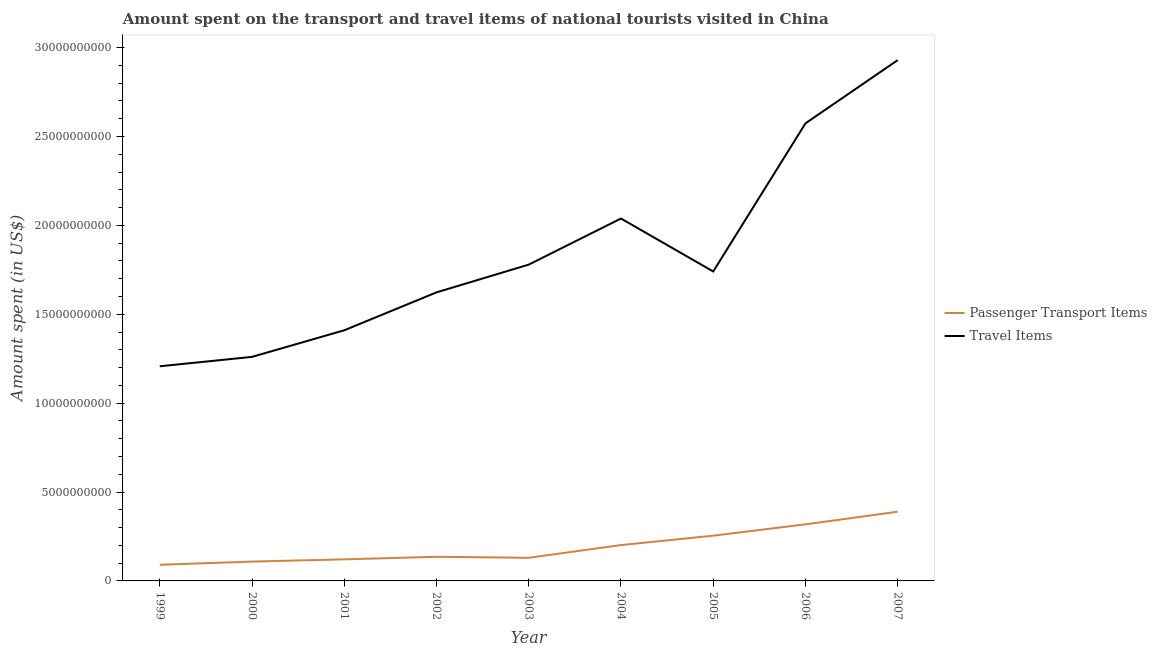Is the number of lines equal to the number of legend labels?
Your response must be concise. Yes. What is the amount spent in travel items in 2007?
Provide a succinct answer. 2.93e+1. Across all years, what is the maximum amount spent in travel items?
Offer a terse response. 2.93e+1. Across all years, what is the minimum amount spent on passenger transport items?
Your answer should be very brief. 9.08e+08. In which year was the amount spent on passenger transport items maximum?
Provide a succinct answer. 2007. What is the total amount spent in travel items in the graph?
Make the answer very short. 1.66e+11. What is the difference between the amount spent in travel items in 2003 and that in 2006?
Provide a succinct answer. -7.95e+09. What is the difference between the amount spent in travel items in 1999 and the amount spent on passenger transport items in 2004?
Your answer should be very brief. 1.01e+1. What is the average amount spent on passenger transport items per year?
Give a very brief answer. 1.94e+09. In the year 2003, what is the difference between the amount spent on passenger transport items and amount spent in travel items?
Provide a short and direct response. -1.65e+1. In how many years, is the amount spent on passenger transport items greater than 25000000000 US$?
Offer a very short reply. 0. What is the ratio of the amount spent on passenger transport items in 2001 to that in 2003?
Offer a terse response. 0.93. What is the difference between the highest and the second highest amount spent in travel items?
Provide a succinct answer. 3.56e+09. What is the difference between the highest and the lowest amount spent in travel items?
Offer a very short reply. 1.72e+1. Is the sum of the amount spent in travel items in 1999 and 2002 greater than the maximum amount spent on passenger transport items across all years?
Your response must be concise. Yes. Is the amount spent in travel items strictly less than the amount spent on passenger transport items over the years?
Offer a very short reply. No. What is the difference between two consecutive major ticks on the Y-axis?
Your answer should be compact. 5.00e+09. Does the graph contain grids?
Offer a terse response. No. How many legend labels are there?
Ensure brevity in your answer.  2. What is the title of the graph?
Keep it short and to the point. Amount spent on the transport and travel items of national tourists visited in China. What is the label or title of the Y-axis?
Offer a terse response. Amount spent (in US$). What is the Amount spent (in US$) in Passenger Transport Items in 1999?
Provide a succinct answer. 9.08e+08. What is the Amount spent (in US$) in Travel Items in 1999?
Provide a succinct answer. 1.21e+1. What is the Amount spent (in US$) of Passenger Transport Items in 2000?
Give a very brief answer. 1.09e+09. What is the Amount spent (in US$) of Travel Items in 2000?
Ensure brevity in your answer.  1.26e+1. What is the Amount spent (in US$) of Passenger Transport Items in 2001?
Ensure brevity in your answer.  1.21e+09. What is the Amount spent (in US$) in Travel Items in 2001?
Provide a short and direct response. 1.41e+1. What is the Amount spent (in US$) of Passenger Transport Items in 2002?
Give a very brief answer. 1.36e+09. What is the Amount spent (in US$) of Travel Items in 2002?
Provide a short and direct response. 1.62e+1. What is the Amount spent (in US$) in Passenger Transport Items in 2003?
Your answer should be very brief. 1.30e+09. What is the Amount spent (in US$) of Travel Items in 2003?
Make the answer very short. 1.78e+1. What is the Amount spent (in US$) of Passenger Transport Items in 2004?
Offer a terse response. 2.02e+09. What is the Amount spent (in US$) in Travel Items in 2004?
Your answer should be compact. 2.04e+1. What is the Amount spent (in US$) of Passenger Transport Items in 2005?
Ensure brevity in your answer.  2.55e+09. What is the Amount spent (in US$) in Travel Items in 2005?
Offer a terse response. 1.74e+1. What is the Amount spent (in US$) in Passenger Transport Items in 2006?
Your answer should be compact. 3.18e+09. What is the Amount spent (in US$) in Travel Items in 2006?
Make the answer very short. 2.57e+1. What is the Amount spent (in US$) in Passenger Transport Items in 2007?
Your answer should be very brief. 3.89e+09. What is the Amount spent (in US$) in Travel Items in 2007?
Keep it short and to the point. 2.93e+1. Across all years, what is the maximum Amount spent (in US$) in Passenger Transport Items?
Ensure brevity in your answer.  3.89e+09. Across all years, what is the maximum Amount spent (in US$) of Travel Items?
Make the answer very short. 2.93e+1. Across all years, what is the minimum Amount spent (in US$) in Passenger Transport Items?
Make the answer very short. 9.08e+08. Across all years, what is the minimum Amount spent (in US$) in Travel Items?
Offer a very short reply. 1.21e+1. What is the total Amount spent (in US$) of Passenger Transport Items in the graph?
Give a very brief answer. 1.75e+1. What is the total Amount spent (in US$) in Travel Items in the graph?
Keep it short and to the point. 1.66e+11. What is the difference between the Amount spent (in US$) of Passenger Transport Items in 1999 and that in 2000?
Offer a terse response. -1.79e+08. What is the difference between the Amount spent (in US$) in Travel Items in 1999 and that in 2000?
Provide a short and direct response. -5.28e+08. What is the difference between the Amount spent (in US$) in Passenger Transport Items in 1999 and that in 2001?
Offer a very short reply. -3.06e+08. What is the difference between the Amount spent (in US$) of Travel Items in 1999 and that in 2001?
Keep it short and to the point. -2.02e+09. What is the difference between the Amount spent (in US$) in Passenger Transport Items in 1999 and that in 2002?
Keep it short and to the point. -4.49e+08. What is the difference between the Amount spent (in US$) in Travel Items in 1999 and that in 2002?
Make the answer very short. -4.16e+09. What is the difference between the Amount spent (in US$) of Passenger Transport Items in 1999 and that in 2003?
Make the answer very short. -3.93e+08. What is the difference between the Amount spent (in US$) in Travel Items in 1999 and that in 2003?
Give a very brief answer. -5.72e+09. What is the difference between the Amount spent (in US$) in Passenger Transport Items in 1999 and that in 2004?
Offer a very short reply. -1.11e+09. What is the difference between the Amount spent (in US$) of Travel Items in 1999 and that in 2004?
Offer a very short reply. -8.31e+09. What is the difference between the Amount spent (in US$) of Passenger Transport Items in 1999 and that in 2005?
Provide a succinct answer. -1.64e+09. What is the difference between the Amount spent (in US$) of Travel Items in 1999 and that in 2005?
Your answer should be very brief. -5.33e+09. What is the difference between the Amount spent (in US$) in Passenger Transport Items in 1999 and that in 2006?
Provide a short and direct response. -2.28e+09. What is the difference between the Amount spent (in US$) in Travel Items in 1999 and that in 2006?
Your answer should be compact. -1.37e+1. What is the difference between the Amount spent (in US$) of Passenger Transport Items in 1999 and that in 2007?
Ensure brevity in your answer.  -2.98e+09. What is the difference between the Amount spent (in US$) in Travel Items in 1999 and that in 2007?
Your answer should be compact. -1.72e+1. What is the difference between the Amount spent (in US$) in Passenger Transport Items in 2000 and that in 2001?
Offer a terse response. -1.27e+08. What is the difference between the Amount spent (in US$) of Travel Items in 2000 and that in 2001?
Keep it short and to the point. -1.50e+09. What is the difference between the Amount spent (in US$) in Passenger Transport Items in 2000 and that in 2002?
Offer a very short reply. -2.70e+08. What is the difference between the Amount spent (in US$) of Travel Items in 2000 and that in 2002?
Provide a short and direct response. -3.63e+09. What is the difference between the Amount spent (in US$) in Passenger Transport Items in 2000 and that in 2003?
Your answer should be very brief. -2.14e+08. What is the difference between the Amount spent (in US$) of Travel Items in 2000 and that in 2003?
Make the answer very short. -5.19e+09. What is the difference between the Amount spent (in US$) in Passenger Transport Items in 2000 and that in 2004?
Provide a short and direct response. -9.29e+08. What is the difference between the Amount spent (in US$) of Travel Items in 2000 and that in 2004?
Your answer should be very brief. -7.78e+09. What is the difference between the Amount spent (in US$) of Passenger Transport Items in 2000 and that in 2005?
Offer a very short reply. -1.46e+09. What is the difference between the Amount spent (in US$) of Travel Items in 2000 and that in 2005?
Offer a very short reply. -4.80e+09. What is the difference between the Amount spent (in US$) in Passenger Transport Items in 2000 and that in 2006?
Give a very brief answer. -2.10e+09. What is the difference between the Amount spent (in US$) in Travel Items in 2000 and that in 2006?
Ensure brevity in your answer.  -1.31e+1. What is the difference between the Amount spent (in US$) of Passenger Transport Items in 2000 and that in 2007?
Your response must be concise. -2.81e+09. What is the difference between the Amount spent (in US$) of Travel Items in 2000 and that in 2007?
Your answer should be very brief. -1.67e+1. What is the difference between the Amount spent (in US$) in Passenger Transport Items in 2001 and that in 2002?
Make the answer very short. -1.43e+08. What is the difference between the Amount spent (in US$) in Travel Items in 2001 and that in 2002?
Offer a terse response. -2.13e+09. What is the difference between the Amount spent (in US$) in Passenger Transport Items in 2001 and that in 2003?
Your answer should be very brief. -8.70e+07. What is the difference between the Amount spent (in US$) of Travel Items in 2001 and that in 2003?
Make the answer very short. -3.69e+09. What is the difference between the Amount spent (in US$) of Passenger Transport Items in 2001 and that in 2004?
Provide a short and direct response. -8.02e+08. What is the difference between the Amount spent (in US$) in Travel Items in 2001 and that in 2004?
Offer a very short reply. -6.29e+09. What is the difference between the Amount spent (in US$) in Passenger Transport Items in 2001 and that in 2005?
Your answer should be very brief. -1.33e+09. What is the difference between the Amount spent (in US$) of Travel Items in 2001 and that in 2005?
Your answer should be compact. -3.31e+09. What is the difference between the Amount spent (in US$) in Passenger Transport Items in 2001 and that in 2006?
Provide a short and direct response. -1.97e+09. What is the difference between the Amount spent (in US$) in Travel Items in 2001 and that in 2006?
Provide a short and direct response. -1.16e+1. What is the difference between the Amount spent (in US$) in Passenger Transport Items in 2001 and that in 2007?
Your response must be concise. -2.68e+09. What is the difference between the Amount spent (in US$) in Travel Items in 2001 and that in 2007?
Your answer should be compact. -1.52e+1. What is the difference between the Amount spent (in US$) in Passenger Transport Items in 2002 and that in 2003?
Your answer should be compact. 5.60e+07. What is the difference between the Amount spent (in US$) of Travel Items in 2002 and that in 2003?
Ensure brevity in your answer.  -1.56e+09. What is the difference between the Amount spent (in US$) in Passenger Transport Items in 2002 and that in 2004?
Offer a terse response. -6.59e+08. What is the difference between the Amount spent (in US$) in Travel Items in 2002 and that in 2004?
Provide a short and direct response. -4.15e+09. What is the difference between the Amount spent (in US$) in Passenger Transport Items in 2002 and that in 2005?
Provide a succinct answer. -1.19e+09. What is the difference between the Amount spent (in US$) in Travel Items in 2002 and that in 2005?
Provide a succinct answer. -1.18e+09. What is the difference between the Amount spent (in US$) of Passenger Transport Items in 2002 and that in 2006?
Offer a very short reply. -1.83e+09. What is the difference between the Amount spent (in US$) in Travel Items in 2002 and that in 2006?
Ensure brevity in your answer.  -9.51e+09. What is the difference between the Amount spent (in US$) of Passenger Transport Items in 2002 and that in 2007?
Your response must be concise. -2.54e+09. What is the difference between the Amount spent (in US$) of Travel Items in 2002 and that in 2007?
Your answer should be compact. -1.31e+1. What is the difference between the Amount spent (in US$) of Passenger Transport Items in 2003 and that in 2004?
Provide a short and direct response. -7.15e+08. What is the difference between the Amount spent (in US$) in Travel Items in 2003 and that in 2004?
Keep it short and to the point. -2.59e+09. What is the difference between the Amount spent (in US$) of Passenger Transport Items in 2003 and that in 2005?
Provide a short and direct response. -1.24e+09. What is the difference between the Amount spent (in US$) in Travel Items in 2003 and that in 2005?
Your answer should be very brief. 3.86e+08. What is the difference between the Amount spent (in US$) in Passenger Transport Items in 2003 and that in 2006?
Your answer should be very brief. -1.88e+09. What is the difference between the Amount spent (in US$) in Travel Items in 2003 and that in 2006?
Offer a terse response. -7.95e+09. What is the difference between the Amount spent (in US$) of Passenger Transport Items in 2003 and that in 2007?
Your answer should be compact. -2.59e+09. What is the difference between the Amount spent (in US$) of Travel Items in 2003 and that in 2007?
Your answer should be compact. -1.15e+1. What is the difference between the Amount spent (in US$) in Passenger Transport Items in 2004 and that in 2005?
Your answer should be very brief. -5.30e+08. What is the difference between the Amount spent (in US$) of Travel Items in 2004 and that in 2005?
Provide a succinct answer. 2.98e+09. What is the difference between the Amount spent (in US$) of Passenger Transport Items in 2004 and that in 2006?
Make the answer very short. -1.17e+09. What is the difference between the Amount spent (in US$) of Travel Items in 2004 and that in 2006?
Your answer should be very brief. -5.35e+09. What is the difference between the Amount spent (in US$) of Passenger Transport Items in 2004 and that in 2007?
Your answer should be compact. -1.88e+09. What is the difference between the Amount spent (in US$) of Travel Items in 2004 and that in 2007?
Your answer should be compact. -8.91e+09. What is the difference between the Amount spent (in US$) in Passenger Transport Items in 2005 and that in 2006?
Make the answer very short. -6.37e+08. What is the difference between the Amount spent (in US$) in Travel Items in 2005 and that in 2006?
Your answer should be very brief. -8.33e+09. What is the difference between the Amount spent (in US$) in Passenger Transport Items in 2005 and that in 2007?
Offer a very short reply. -1.35e+09. What is the difference between the Amount spent (in US$) in Travel Items in 2005 and that in 2007?
Your response must be concise. -1.19e+1. What is the difference between the Amount spent (in US$) in Passenger Transport Items in 2006 and that in 2007?
Ensure brevity in your answer.  -7.10e+08. What is the difference between the Amount spent (in US$) in Travel Items in 2006 and that in 2007?
Provide a succinct answer. -3.56e+09. What is the difference between the Amount spent (in US$) in Passenger Transport Items in 1999 and the Amount spent (in US$) in Travel Items in 2000?
Provide a succinct answer. -1.17e+1. What is the difference between the Amount spent (in US$) of Passenger Transport Items in 1999 and the Amount spent (in US$) of Travel Items in 2001?
Your answer should be very brief. -1.32e+1. What is the difference between the Amount spent (in US$) of Passenger Transport Items in 1999 and the Amount spent (in US$) of Travel Items in 2002?
Your response must be concise. -1.53e+1. What is the difference between the Amount spent (in US$) in Passenger Transport Items in 1999 and the Amount spent (in US$) in Travel Items in 2003?
Ensure brevity in your answer.  -1.69e+1. What is the difference between the Amount spent (in US$) in Passenger Transport Items in 1999 and the Amount spent (in US$) in Travel Items in 2004?
Offer a terse response. -1.95e+1. What is the difference between the Amount spent (in US$) of Passenger Transport Items in 1999 and the Amount spent (in US$) of Travel Items in 2005?
Your response must be concise. -1.65e+1. What is the difference between the Amount spent (in US$) of Passenger Transport Items in 1999 and the Amount spent (in US$) of Travel Items in 2006?
Keep it short and to the point. -2.48e+1. What is the difference between the Amount spent (in US$) of Passenger Transport Items in 1999 and the Amount spent (in US$) of Travel Items in 2007?
Your answer should be very brief. -2.84e+1. What is the difference between the Amount spent (in US$) in Passenger Transport Items in 2000 and the Amount spent (in US$) in Travel Items in 2001?
Provide a short and direct response. -1.30e+1. What is the difference between the Amount spent (in US$) in Passenger Transport Items in 2000 and the Amount spent (in US$) in Travel Items in 2002?
Provide a short and direct response. -1.51e+1. What is the difference between the Amount spent (in US$) in Passenger Transport Items in 2000 and the Amount spent (in US$) in Travel Items in 2003?
Your answer should be compact. -1.67e+1. What is the difference between the Amount spent (in US$) of Passenger Transport Items in 2000 and the Amount spent (in US$) of Travel Items in 2004?
Provide a short and direct response. -1.93e+1. What is the difference between the Amount spent (in US$) of Passenger Transport Items in 2000 and the Amount spent (in US$) of Travel Items in 2005?
Ensure brevity in your answer.  -1.63e+1. What is the difference between the Amount spent (in US$) of Passenger Transport Items in 2000 and the Amount spent (in US$) of Travel Items in 2006?
Make the answer very short. -2.47e+1. What is the difference between the Amount spent (in US$) in Passenger Transport Items in 2000 and the Amount spent (in US$) in Travel Items in 2007?
Offer a very short reply. -2.82e+1. What is the difference between the Amount spent (in US$) of Passenger Transport Items in 2001 and the Amount spent (in US$) of Travel Items in 2002?
Provide a short and direct response. -1.50e+1. What is the difference between the Amount spent (in US$) in Passenger Transport Items in 2001 and the Amount spent (in US$) in Travel Items in 2003?
Your answer should be compact. -1.66e+1. What is the difference between the Amount spent (in US$) in Passenger Transport Items in 2001 and the Amount spent (in US$) in Travel Items in 2004?
Give a very brief answer. -1.92e+1. What is the difference between the Amount spent (in US$) in Passenger Transport Items in 2001 and the Amount spent (in US$) in Travel Items in 2005?
Your response must be concise. -1.62e+1. What is the difference between the Amount spent (in US$) of Passenger Transport Items in 2001 and the Amount spent (in US$) of Travel Items in 2006?
Keep it short and to the point. -2.45e+1. What is the difference between the Amount spent (in US$) of Passenger Transport Items in 2001 and the Amount spent (in US$) of Travel Items in 2007?
Ensure brevity in your answer.  -2.81e+1. What is the difference between the Amount spent (in US$) of Passenger Transport Items in 2002 and the Amount spent (in US$) of Travel Items in 2003?
Ensure brevity in your answer.  -1.64e+1. What is the difference between the Amount spent (in US$) in Passenger Transport Items in 2002 and the Amount spent (in US$) in Travel Items in 2004?
Your answer should be very brief. -1.90e+1. What is the difference between the Amount spent (in US$) in Passenger Transport Items in 2002 and the Amount spent (in US$) in Travel Items in 2005?
Your response must be concise. -1.60e+1. What is the difference between the Amount spent (in US$) of Passenger Transport Items in 2002 and the Amount spent (in US$) of Travel Items in 2006?
Provide a succinct answer. -2.44e+1. What is the difference between the Amount spent (in US$) of Passenger Transport Items in 2002 and the Amount spent (in US$) of Travel Items in 2007?
Provide a short and direct response. -2.79e+1. What is the difference between the Amount spent (in US$) of Passenger Transport Items in 2003 and the Amount spent (in US$) of Travel Items in 2004?
Your response must be concise. -1.91e+1. What is the difference between the Amount spent (in US$) of Passenger Transport Items in 2003 and the Amount spent (in US$) of Travel Items in 2005?
Provide a short and direct response. -1.61e+1. What is the difference between the Amount spent (in US$) of Passenger Transport Items in 2003 and the Amount spent (in US$) of Travel Items in 2006?
Make the answer very short. -2.44e+1. What is the difference between the Amount spent (in US$) of Passenger Transport Items in 2003 and the Amount spent (in US$) of Travel Items in 2007?
Your answer should be compact. -2.80e+1. What is the difference between the Amount spent (in US$) in Passenger Transport Items in 2004 and the Amount spent (in US$) in Travel Items in 2005?
Your answer should be very brief. -1.54e+1. What is the difference between the Amount spent (in US$) in Passenger Transport Items in 2004 and the Amount spent (in US$) in Travel Items in 2006?
Ensure brevity in your answer.  -2.37e+1. What is the difference between the Amount spent (in US$) in Passenger Transport Items in 2004 and the Amount spent (in US$) in Travel Items in 2007?
Keep it short and to the point. -2.73e+1. What is the difference between the Amount spent (in US$) of Passenger Transport Items in 2005 and the Amount spent (in US$) of Travel Items in 2006?
Give a very brief answer. -2.32e+1. What is the difference between the Amount spent (in US$) of Passenger Transport Items in 2005 and the Amount spent (in US$) of Travel Items in 2007?
Provide a short and direct response. -2.68e+1. What is the difference between the Amount spent (in US$) of Passenger Transport Items in 2006 and the Amount spent (in US$) of Travel Items in 2007?
Keep it short and to the point. -2.61e+1. What is the average Amount spent (in US$) in Passenger Transport Items per year?
Your response must be concise. 1.94e+09. What is the average Amount spent (in US$) of Travel Items per year?
Offer a terse response. 1.84e+1. In the year 1999, what is the difference between the Amount spent (in US$) in Passenger Transport Items and Amount spent (in US$) in Travel Items?
Make the answer very short. -1.12e+1. In the year 2000, what is the difference between the Amount spent (in US$) of Passenger Transport Items and Amount spent (in US$) of Travel Items?
Your answer should be compact. -1.15e+1. In the year 2001, what is the difference between the Amount spent (in US$) in Passenger Transport Items and Amount spent (in US$) in Travel Items?
Your response must be concise. -1.29e+1. In the year 2002, what is the difference between the Amount spent (in US$) in Passenger Transport Items and Amount spent (in US$) in Travel Items?
Keep it short and to the point. -1.49e+1. In the year 2003, what is the difference between the Amount spent (in US$) of Passenger Transport Items and Amount spent (in US$) of Travel Items?
Give a very brief answer. -1.65e+1. In the year 2004, what is the difference between the Amount spent (in US$) of Passenger Transport Items and Amount spent (in US$) of Travel Items?
Provide a short and direct response. -1.84e+1. In the year 2005, what is the difference between the Amount spent (in US$) in Passenger Transport Items and Amount spent (in US$) in Travel Items?
Give a very brief answer. -1.49e+1. In the year 2006, what is the difference between the Amount spent (in US$) of Passenger Transport Items and Amount spent (in US$) of Travel Items?
Offer a terse response. -2.26e+1. In the year 2007, what is the difference between the Amount spent (in US$) in Passenger Transport Items and Amount spent (in US$) in Travel Items?
Your answer should be very brief. -2.54e+1. What is the ratio of the Amount spent (in US$) of Passenger Transport Items in 1999 to that in 2000?
Provide a short and direct response. 0.84. What is the ratio of the Amount spent (in US$) in Travel Items in 1999 to that in 2000?
Offer a very short reply. 0.96. What is the ratio of the Amount spent (in US$) in Passenger Transport Items in 1999 to that in 2001?
Ensure brevity in your answer.  0.75. What is the ratio of the Amount spent (in US$) of Travel Items in 1999 to that in 2001?
Ensure brevity in your answer.  0.86. What is the ratio of the Amount spent (in US$) of Passenger Transport Items in 1999 to that in 2002?
Your response must be concise. 0.67. What is the ratio of the Amount spent (in US$) of Travel Items in 1999 to that in 2002?
Ensure brevity in your answer.  0.74. What is the ratio of the Amount spent (in US$) of Passenger Transport Items in 1999 to that in 2003?
Make the answer very short. 0.7. What is the ratio of the Amount spent (in US$) in Travel Items in 1999 to that in 2003?
Keep it short and to the point. 0.68. What is the ratio of the Amount spent (in US$) of Passenger Transport Items in 1999 to that in 2004?
Your answer should be compact. 0.45. What is the ratio of the Amount spent (in US$) of Travel Items in 1999 to that in 2004?
Ensure brevity in your answer.  0.59. What is the ratio of the Amount spent (in US$) in Passenger Transport Items in 1999 to that in 2005?
Provide a succinct answer. 0.36. What is the ratio of the Amount spent (in US$) of Travel Items in 1999 to that in 2005?
Make the answer very short. 0.69. What is the ratio of the Amount spent (in US$) in Passenger Transport Items in 1999 to that in 2006?
Give a very brief answer. 0.29. What is the ratio of the Amount spent (in US$) of Travel Items in 1999 to that in 2006?
Ensure brevity in your answer.  0.47. What is the ratio of the Amount spent (in US$) of Passenger Transport Items in 1999 to that in 2007?
Provide a short and direct response. 0.23. What is the ratio of the Amount spent (in US$) in Travel Items in 1999 to that in 2007?
Your answer should be very brief. 0.41. What is the ratio of the Amount spent (in US$) in Passenger Transport Items in 2000 to that in 2001?
Provide a short and direct response. 0.9. What is the ratio of the Amount spent (in US$) in Travel Items in 2000 to that in 2001?
Provide a succinct answer. 0.89. What is the ratio of the Amount spent (in US$) in Passenger Transport Items in 2000 to that in 2002?
Make the answer very short. 0.8. What is the ratio of the Amount spent (in US$) of Travel Items in 2000 to that in 2002?
Provide a short and direct response. 0.78. What is the ratio of the Amount spent (in US$) in Passenger Transport Items in 2000 to that in 2003?
Your response must be concise. 0.84. What is the ratio of the Amount spent (in US$) in Travel Items in 2000 to that in 2003?
Keep it short and to the point. 0.71. What is the ratio of the Amount spent (in US$) in Passenger Transport Items in 2000 to that in 2004?
Provide a short and direct response. 0.54. What is the ratio of the Amount spent (in US$) of Travel Items in 2000 to that in 2004?
Provide a short and direct response. 0.62. What is the ratio of the Amount spent (in US$) of Passenger Transport Items in 2000 to that in 2005?
Provide a succinct answer. 0.43. What is the ratio of the Amount spent (in US$) in Travel Items in 2000 to that in 2005?
Give a very brief answer. 0.72. What is the ratio of the Amount spent (in US$) in Passenger Transport Items in 2000 to that in 2006?
Your answer should be very brief. 0.34. What is the ratio of the Amount spent (in US$) in Travel Items in 2000 to that in 2006?
Keep it short and to the point. 0.49. What is the ratio of the Amount spent (in US$) of Passenger Transport Items in 2000 to that in 2007?
Give a very brief answer. 0.28. What is the ratio of the Amount spent (in US$) of Travel Items in 2000 to that in 2007?
Keep it short and to the point. 0.43. What is the ratio of the Amount spent (in US$) in Passenger Transport Items in 2001 to that in 2002?
Your response must be concise. 0.89. What is the ratio of the Amount spent (in US$) in Travel Items in 2001 to that in 2002?
Provide a short and direct response. 0.87. What is the ratio of the Amount spent (in US$) of Passenger Transport Items in 2001 to that in 2003?
Offer a very short reply. 0.93. What is the ratio of the Amount spent (in US$) in Travel Items in 2001 to that in 2003?
Give a very brief answer. 0.79. What is the ratio of the Amount spent (in US$) of Passenger Transport Items in 2001 to that in 2004?
Your answer should be compact. 0.6. What is the ratio of the Amount spent (in US$) in Travel Items in 2001 to that in 2004?
Keep it short and to the point. 0.69. What is the ratio of the Amount spent (in US$) in Passenger Transport Items in 2001 to that in 2005?
Make the answer very short. 0.48. What is the ratio of the Amount spent (in US$) of Travel Items in 2001 to that in 2005?
Your answer should be very brief. 0.81. What is the ratio of the Amount spent (in US$) in Passenger Transport Items in 2001 to that in 2006?
Your response must be concise. 0.38. What is the ratio of the Amount spent (in US$) in Travel Items in 2001 to that in 2006?
Provide a succinct answer. 0.55. What is the ratio of the Amount spent (in US$) of Passenger Transport Items in 2001 to that in 2007?
Make the answer very short. 0.31. What is the ratio of the Amount spent (in US$) of Travel Items in 2001 to that in 2007?
Offer a terse response. 0.48. What is the ratio of the Amount spent (in US$) of Passenger Transport Items in 2002 to that in 2003?
Give a very brief answer. 1.04. What is the ratio of the Amount spent (in US$) of Travel Items in 2002 to that in 2003?
Your answer should be very brief. 0.91. What is the ratio of the Amount spent (in US$) in Passenger Transport Items in 2002 to that in 2004?
Your response must be concise. 0.67. What is the ratio of the Amount spent (in US$) of Travel Items in 2002 to that in 2004?
Provide a short and direct response. 0.8. What is the ratio of the Amount spent (in US$) in Passenger Transport Items in 2002 to that in 2005?
Give a very brief answer. 0.53. What is the ratio of the Amount spent (in US$) of Travel Items in 2002 to that in 2005?
Your response must be concise. 0.93. What is the ratio of the Amount spent (in US$) in Passenger Transport Items in 2002 to that in 2006?
Your response must be concise. 0.43. What is the ratio of the Amount spent (in US$) of Travel Items in 2002 to that in 2006?
Provide a succinct answer. 0.63. What is the ratio of the Amount spent (in US$) in Passenger Transport Items in 2002 to that in 2007?
Provide a short and direct response. 0.35. What is the ratio of the Amount spent (in US$) in Travel Items in 2002 to that in 2007?
Provide a short and direct response. 0.55. What is the ratio of the Amount spent (in US$) of Passenger Transport Items in 2003 to that in 2004?
Ensure brevity in your answer.  0.65. What is the ratio of the Amount spent (in US$) in Travel Items in 2003 to that in 2004?
Offer a terse response. 0.87. What is the ratio of the Amount spent (in US$) of Passenger Transport Items in 2003 to that in 2005?
Your answer should be very brief. 0.51. What is the ratio of the Amount spent (in US$) in Travel Items in 2003 to that in 2005?
Make the answer very short. 1.02. What is the ratio of the Amount spent (in US$) in Passenger Transport Items in 2003 to that in 2006?
Make the answer very short. 0.41. What is the ratio of the Amount spent (in US$) in Travel Items in 2003 to that in 2006?
Give a very brief answer. 0.69. What is the ratio of the Amount spent (in US$) of Passenger Transport Items in 2003 to that in 2007?
Your answer should be compact. 0.33. What is the ratio of the Amount spent (in US$) of Travel Items in 2003 to that in 2007?
Offer a very short reply. 0.61. What is the ratio of the Amount spent (in US$) of Passenger Transport Items in 2004 to that in 2005?
Make the answer very short. 0.79. What is the ratio of the Amount spent (in US$) in Travel Items in 2004 to that in 2005?
Keep it short and to the point. 1.17. What is the ratio of the Amount spent (in US$) in Passenger Transport Items in 2004 to that in 2006?
Provide a short and direct response. 0.63. What is the ratio of the Amount spent (in US$) in Travel Items in 2004 to that in 2006?
Give a very brief answer. 0.79. What is the ratio of the Amount spent (in US$) of Passenger Transport Items in 2004 to that in 2007?
Offer a terse response. 0.52. What is the ratio of the Amount spent (in US$) of Travel Items in 2004 to that in 2007?
Your response must be concise. 0.7. What is the ratio of the Amount spent (in US$) of Passenger Transport Items in 2005 to that in 2006?
Give a very brief answer. 0.8. What is the ratio of the Amount spent (in US$) of Travel Items in 2005 to that in 2006?
Your response must be concise. 0.68. What is the ratio of the Amount spent (in US$) in Passenger Transport Items in 2005 to that in 2007?
Ensure brevity in your answer.  0.65. What is the ratio of the Amount spent (in US$) of Travel Items in 2005 to that in 2007?
Provide a succinct answer. 0.59. What is the ratio of the Amount spent (in US$) of Passenger Transport Items in 2006 to that in 2007?
Your answer should be compact. 0.82. What is the ratio of the Amount spent (in US$) of Travel Items in 2006 to that in 2007?
Your response must be concise. 0.88. What is the difference between the highest and the second highest Amount spent (in US$) of Passenger Transport Items?
Provide a short and direct response. 7.10e+08. What is the difference between the highest and the second highest Amount spent (in US$) of Travel Items?
Offer a terse response. 3.56e+09. What is the difference between the highest and the lowest Amount spent (in US$) in Passenger Transport Items?
Your answer should be very brief. 2.98e+09. What is the difference between the highest and the lowest Amount spent (in US$) of Travel Items?
Ensure brevity in your answer.  1.72e+1. 